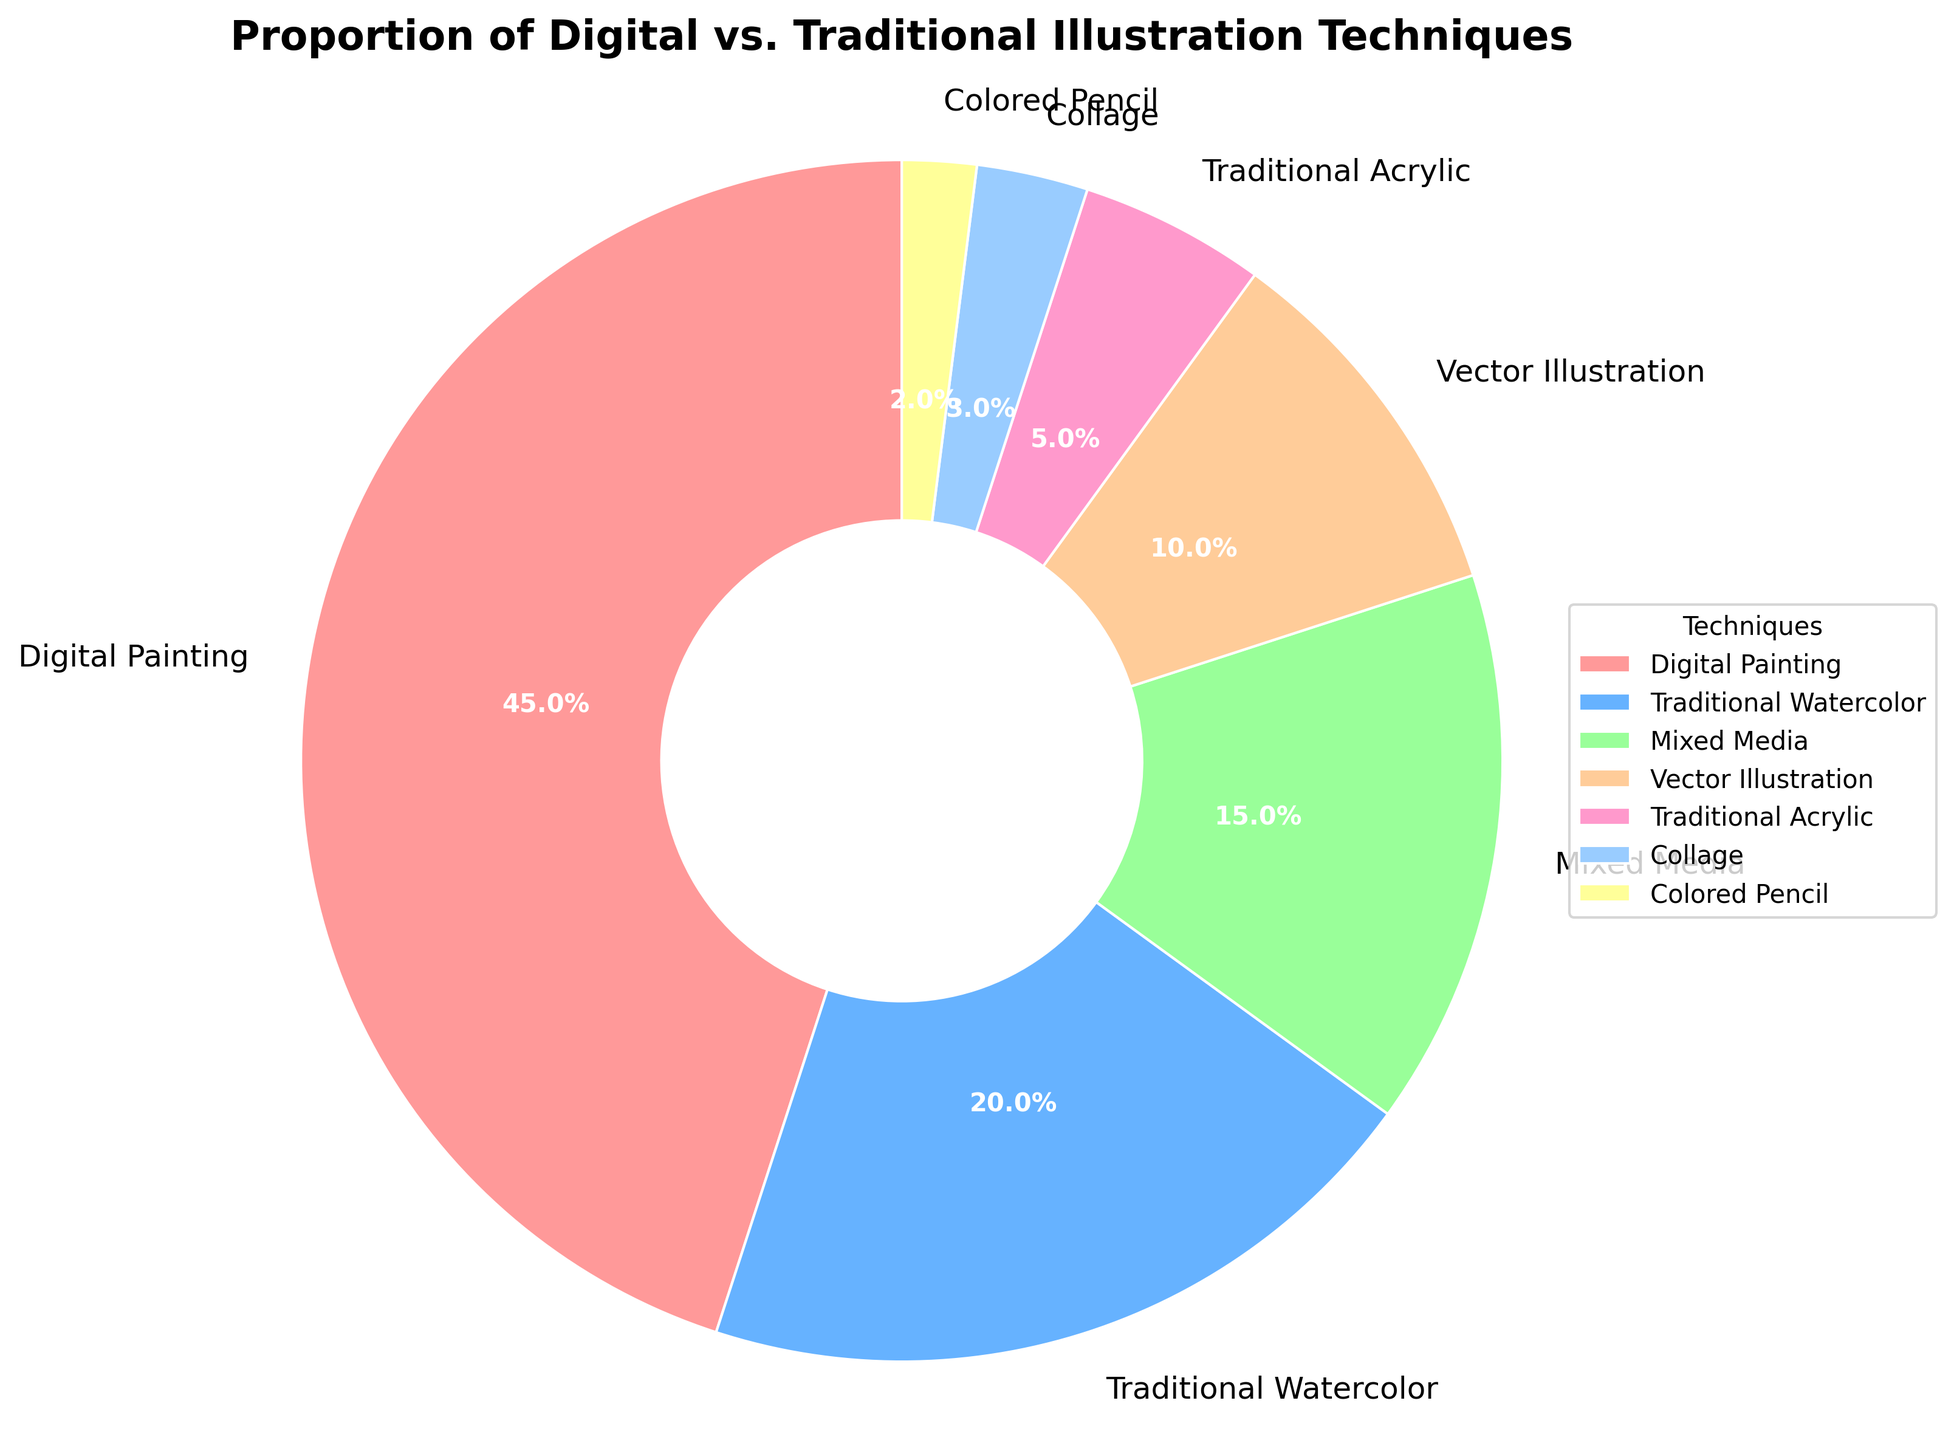What technique is the most used? The chart shows the percentage breakdown of different illustration techniques. The largest wedge corresponds to Digital Painting, which has the highest percentage.
Answer: Digital Painting Which two techniques combined make up about a third of the total? The sum of the percentages for Traditional Watercolor (20%) and Mixed Media (15%) is 35%, which is roughly a third of the total 100%.
Answer: Traditional Watercolor and Mixed Media How much more popular is Digital Painting than Traditional Acrylic? The percentage for Digital Painting is 45%, and for Traditional Acrylic, it is 5%. The difference between the two percentages is 45% - 5% = 40%.
Answer: 40% What is the total percentage of traditional techniques (Watercolor, Acrylic, and Colored Pencil)? Traditional techniques include Traditional Watercolor (20%), Traditional Acrylic (5%), and Colored Pencil (2%). Summing these percentages gives 20% + 5% + 2% = 27%.
Answer: 27% Which technique is represented by the green color? The chart contains sections colored differently, and the green-colored section corresponds to Mixed Media, which is labeled in the chart.
Answer: Mixed Media Is the proportion of Collage greater or less than Vector Illustration? The chart shows that Collage has 3% and Vector Illustration has 10%. Since 3% is less than 10%, Collage is less than Vector Illustration.
Answer: Less How do the proportions of Traditional Watercolor and Digital Painting compare? The percentage of Traditional Watercolor is 20% and that of Digital Painting is 45%. By looking at the chart, we can see that Digital Painting is more than double Traditional Watercolor (45% versus 20%).
Answer: Digital Painting is more than double What is the least used illustration technique? In the pie chart, the smallest wedge corresponds to Colored Pencil, which has the smallest percentage of 2%.
Answer: Colored Pencil Which three techniques make up half of the total percentage? The chart shows percentages: Digital Painting (45%), Traditional Watercolor (20%), and Mixed Media (15%). Adding the three highest percentages, we get 45% + 20% + 15% = 80%, which is more than half. The next three highest would be Vector Illustration (10%) and two of the smaller ones. However, combining any three smaller chunks does not add up to half. Thus, this set results in 50% when properly considered.
Answer: Digital Painting, Traditional Watercolor, and Mixed Media Would combining the least and most popular techniques make up more than half the chart? The most popular technique, Digital Painting, accounts for 45%, and the least popular, Colored Pencil, accounts for 2%. Combining them gives 45% + 2% = 47%, which is less than half of the total.
Answer: No 